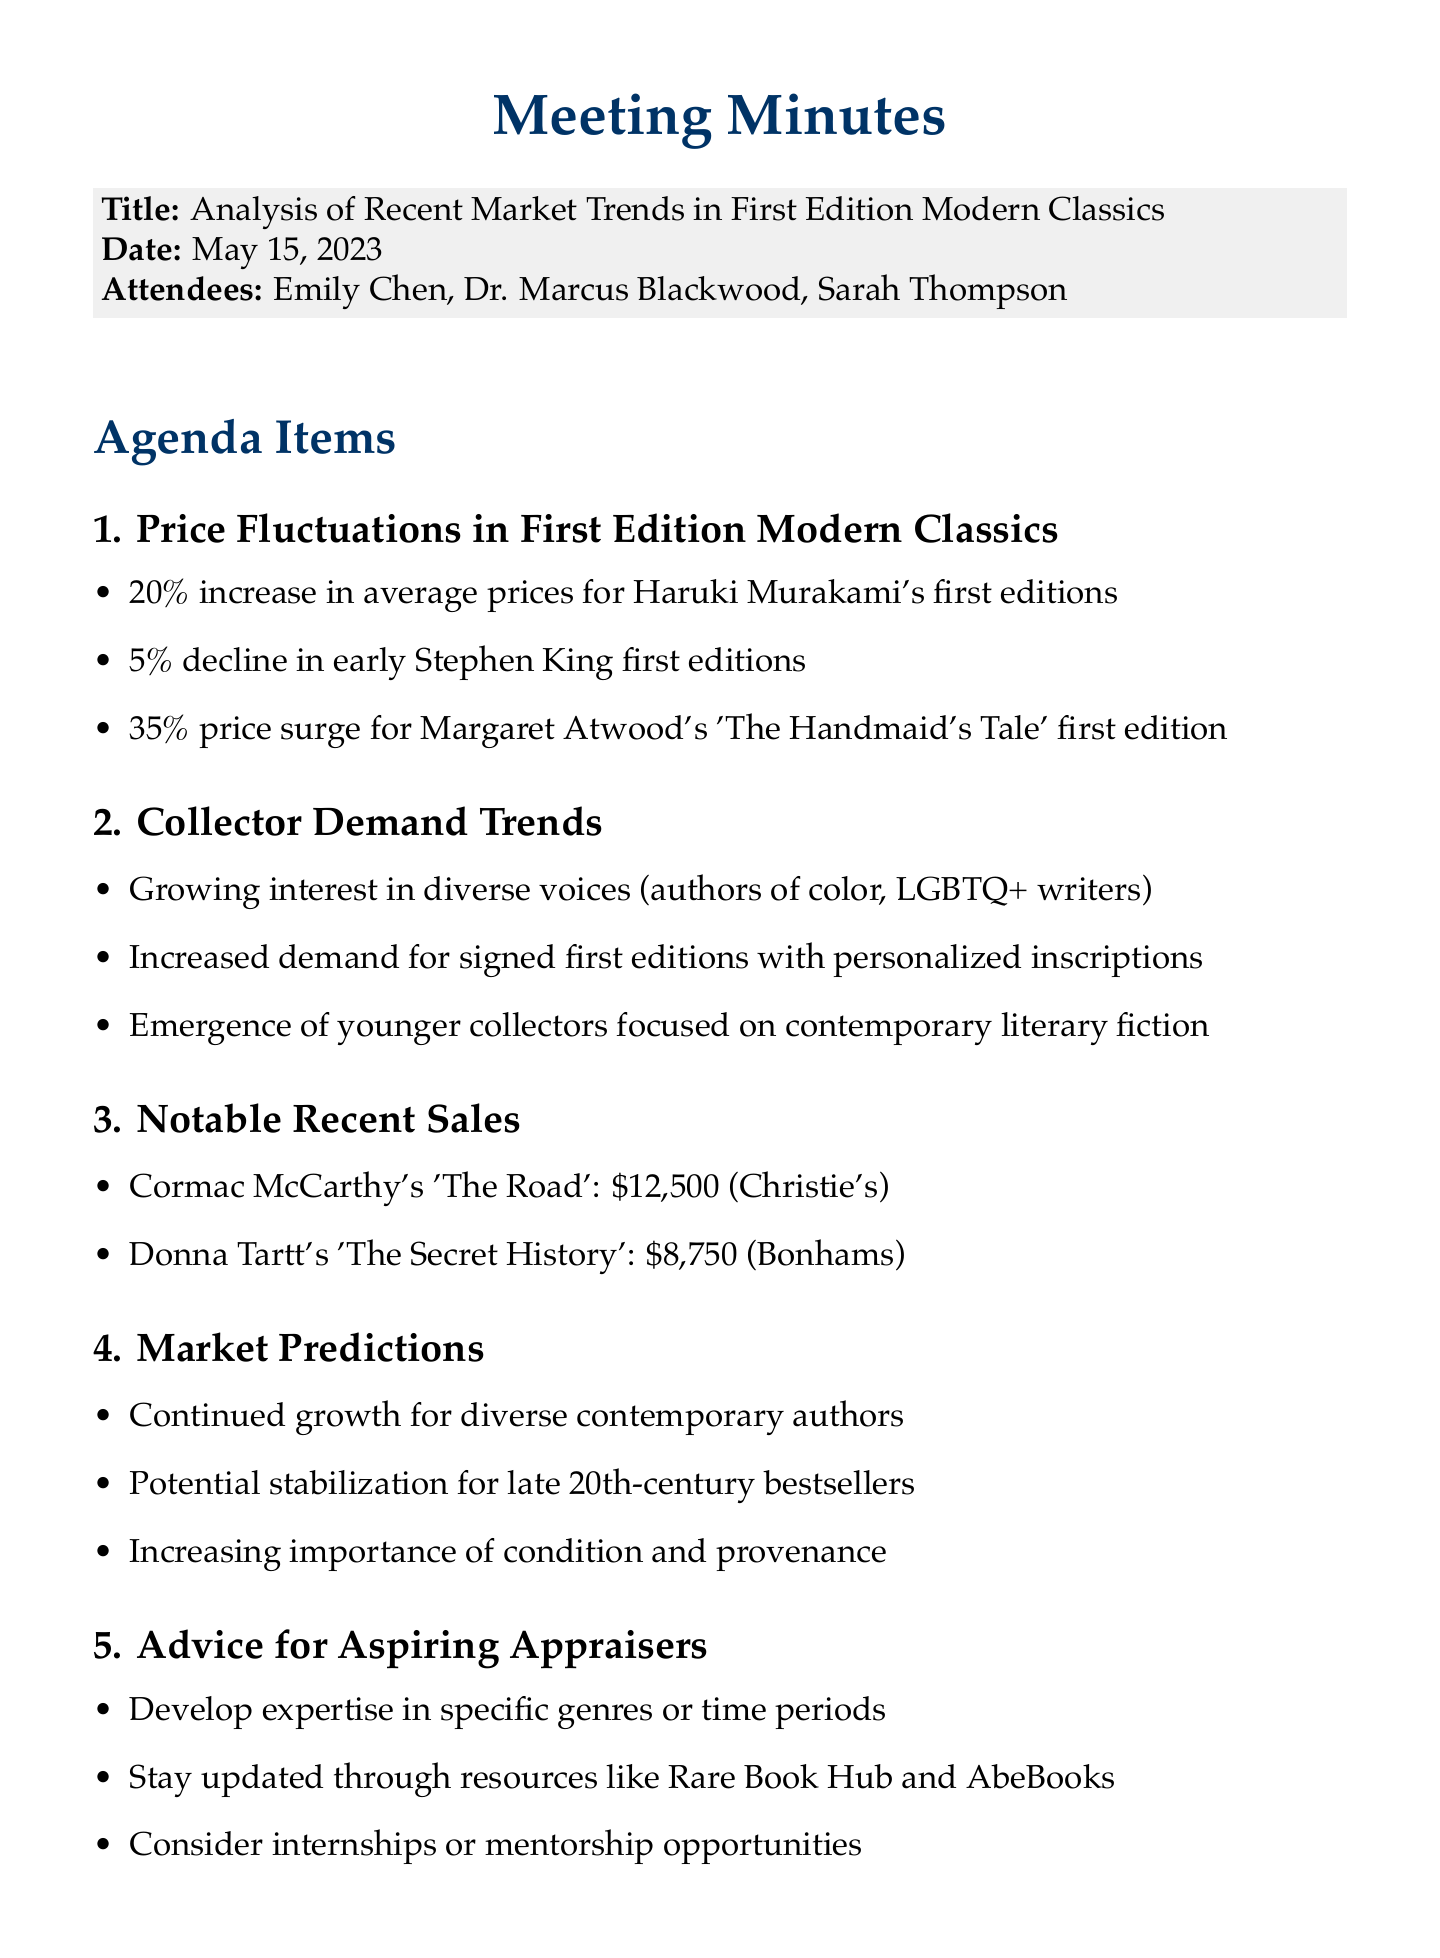What was the date of the meeting? The date of the meeting is stated at the beginning of the document.
Answer: May 15, 2023 Who attended the meeting as the senior appraiser? The document lists Dr. Marcus Blackwood as the senior appraiser among the attendees.
Answer: Dr. Marcus Blackwood What is the percentage increase in average prices for Haruki Murakami's works? The document provides specific percentages for price fluctuations in modern classics, particularly mentioning Haruki Murakami.
Answer: 20% What is a notable trend in collector demand? The document outlines key trends in collector demand for first editions, including a focus on diverse voices.
Answer: Growing interest in diverse voices What was the selling price of Cormac McCarthy's 'The Road'? The document lists notable recent sales, including the price of Cormac McCarthy's book.
Answer: $12,500 What advice is given for aspiring appraisers? The document includes a section advising aspiring appraisers, emphasizing the need for expertise.
Answer: Develop expertise in specific genres or time periods What market prediction is made about late 20th-century bestsellers? The market predictions section mentions an expected trend regarding late 20th-century bestsellers.
Answer: Potential stabilization of prices What action item is assigned to Emily? The document states specific action items, including the task assigned to Emily.
Answer: Research price trends for first editions of literary award winners 